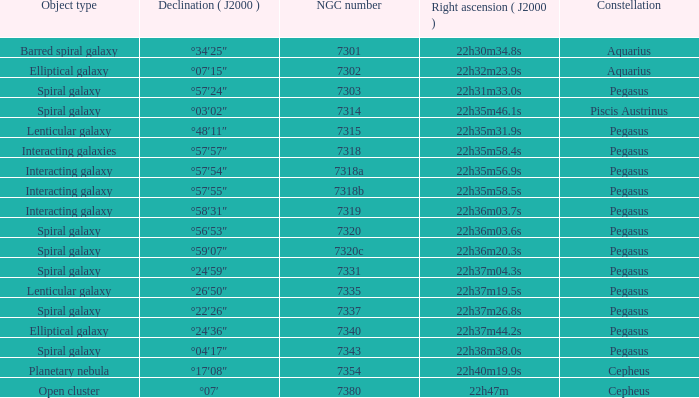What is the right ascension of Pegasus with a 7343 NGC? 22h38m38.0s. 